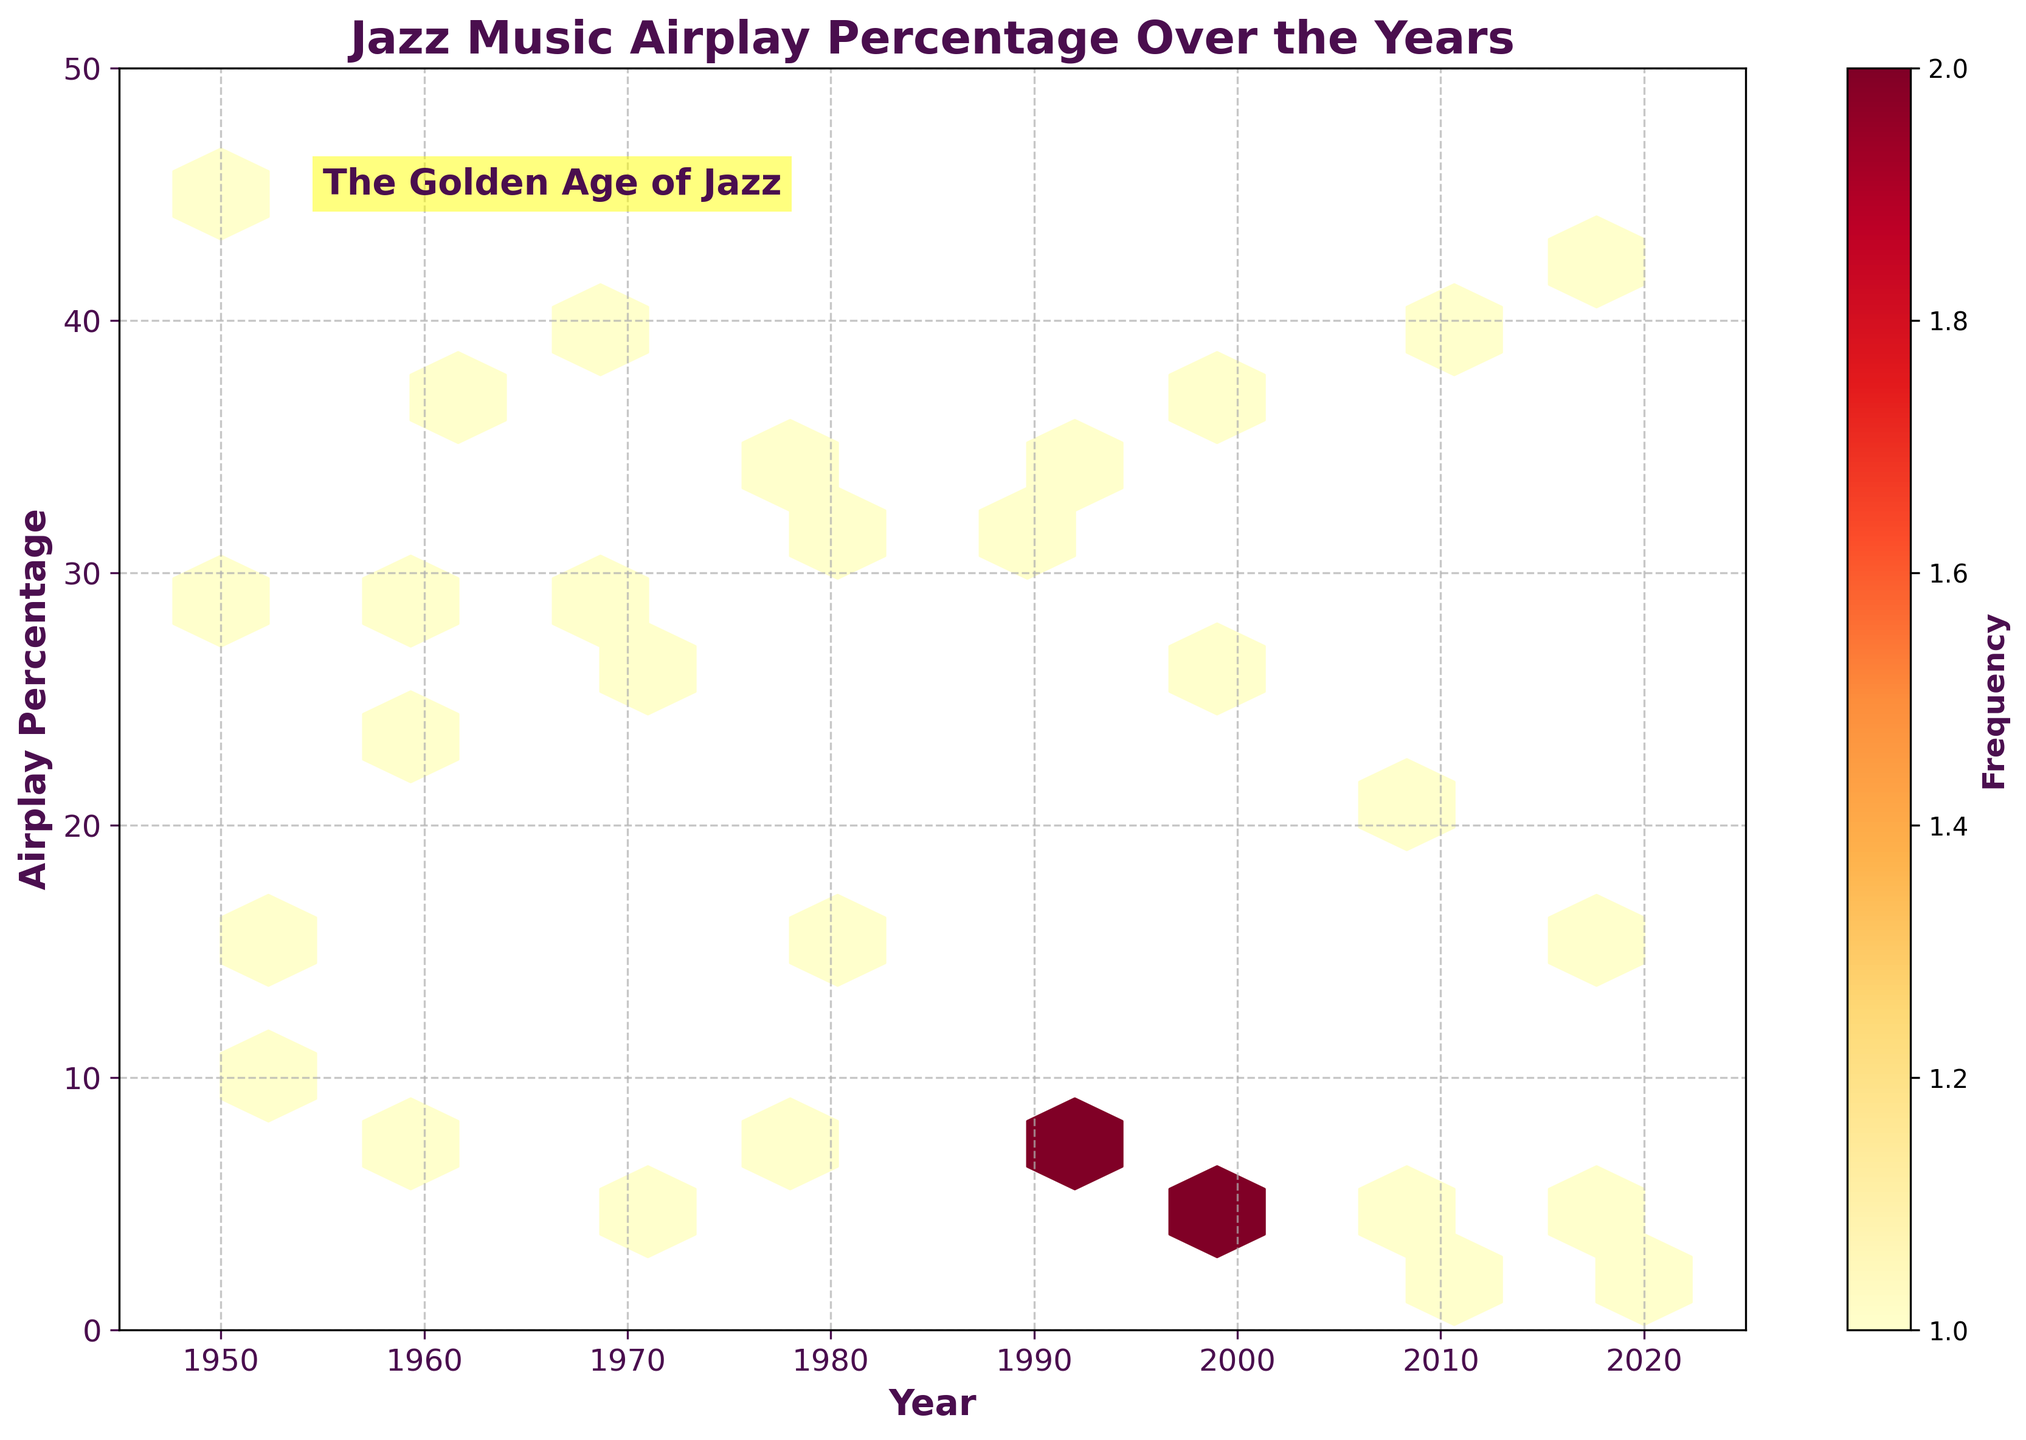What is the title of the figure? The title is usually found at the top of the figure in large, bold text. Here, it states "Jazz Music Airplay Percentage Over the Years."
Answer: Jazz Music Airplay Percentage Over the Years What are the x and y-axis labels? The x-axis label is typically at the bottom of the axis and the y-axis label is on the left side. The x-axis is labeled "Year," and the y-axis is labeled "Airplay Percentage."
Answer: Year, Airplay Percentage How has the airplay percentage of jazz music changed from 1950 to 2020? To answer this, observe the general pattern of hexagons from 1950 to 2020. The percentage starts high around 45% in 1950 and decreases over the years, reaching around 2% in 2020.
Answer: It has decreased During which decade was the airplay percentage of jazz music the highest? Identify the decade with the highest hexagons. In this case, around the 1950s, the airplay percentage was highest at 45%.
Answer: 1950s What other genres are represented in the data aside from Jazz? By assessing patterns in the data or colors, you can see there are indications or annotations for Rock, Pop, and Classical music.
Answer: Rock, Pop, Classical How does the frequency of airplay for jazz music compare to pop music in the year 2020? Compare the hexagons’ positions for Jazz and Pop in 2020 on the y-axis. Jazz is at around 2% while Pop is at 42%.
Answer: Jazz is much lower What is the range of airplay percentage values on the y-axis? Look at the y-axis markings, which range from 0 at the bottom to 50 at the top.
Answer: 0 to 50 During which period was jazz music labeled as the "Golden Age"? According to the text annotation on the plot, the "Golden Age of Jazz" is highlighted around the mid-1950s.
Answer: Mid-1950s What decade shows the largest decline in the airplay percentage of Jazz music? Observe the steepest drop in the vertical positions of hexagons over the decades. The largest decline appears to be between the 1960s and 1970s.
Answer: 1960s to 1970s How does the number of data points vary across the entire plot? The density of hexagons gives an idea of the frequency distribution: there are more hexagons and hence, more data points, in earlier years compared to later years.
Answer: More dense in earlier years, less dense in later years 